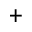Convert formula to latex. <formula><loc_0><loc_0><loc_500><loc_500>^ { + }</formula> 